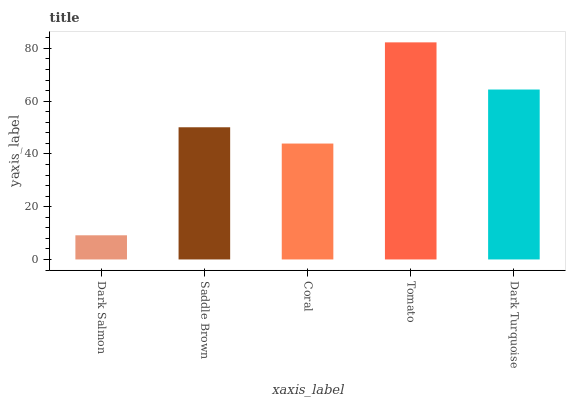Is Saddle Brown the minimum?
Answer yes or no. No. Is Saddle Brown the maximum?
Answer yes or no. No. Is Saddle Brown greater than Dark Salmon?
Answer yes or no. Yes. Is Dark Salmon less than Saddle Brown?
Answer yes or no. Yes. Is Dark Salmon greater than Saddle Brown?
Answer yes or no. No. Is Saddle Brown less than Dark Salmon?
Answer yes or no. No. Is Saddle Brown the high median?
Answer yes or no. Yes. Is Saddle Brown the low median?
Answer yes or no. Yes. Is Dark Salmon the high median?
Answer yes or no. No. Is Dark Salmon the low median?
Answer yes or no. No. 